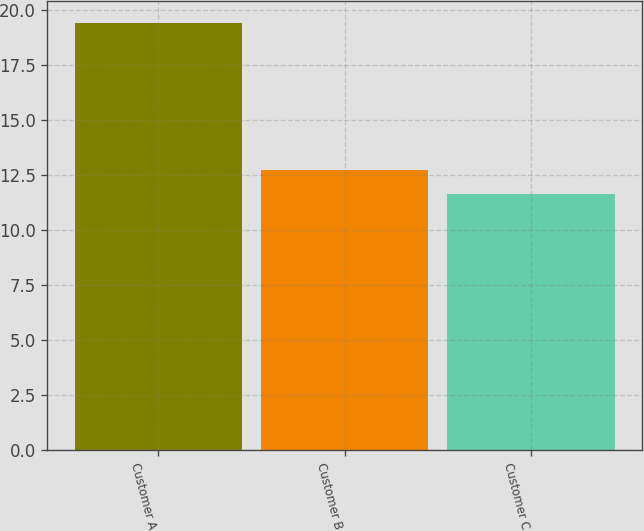Convert chart to OTSL. <chart><loc_0><loc_0><loc_500><loc_500><bar_chart><fcel>Customer A<fcel>Customer B<fcel>Customer C<nl><fcel>19.4<fcel>12.7<fcel>11.6<nl></chart> 